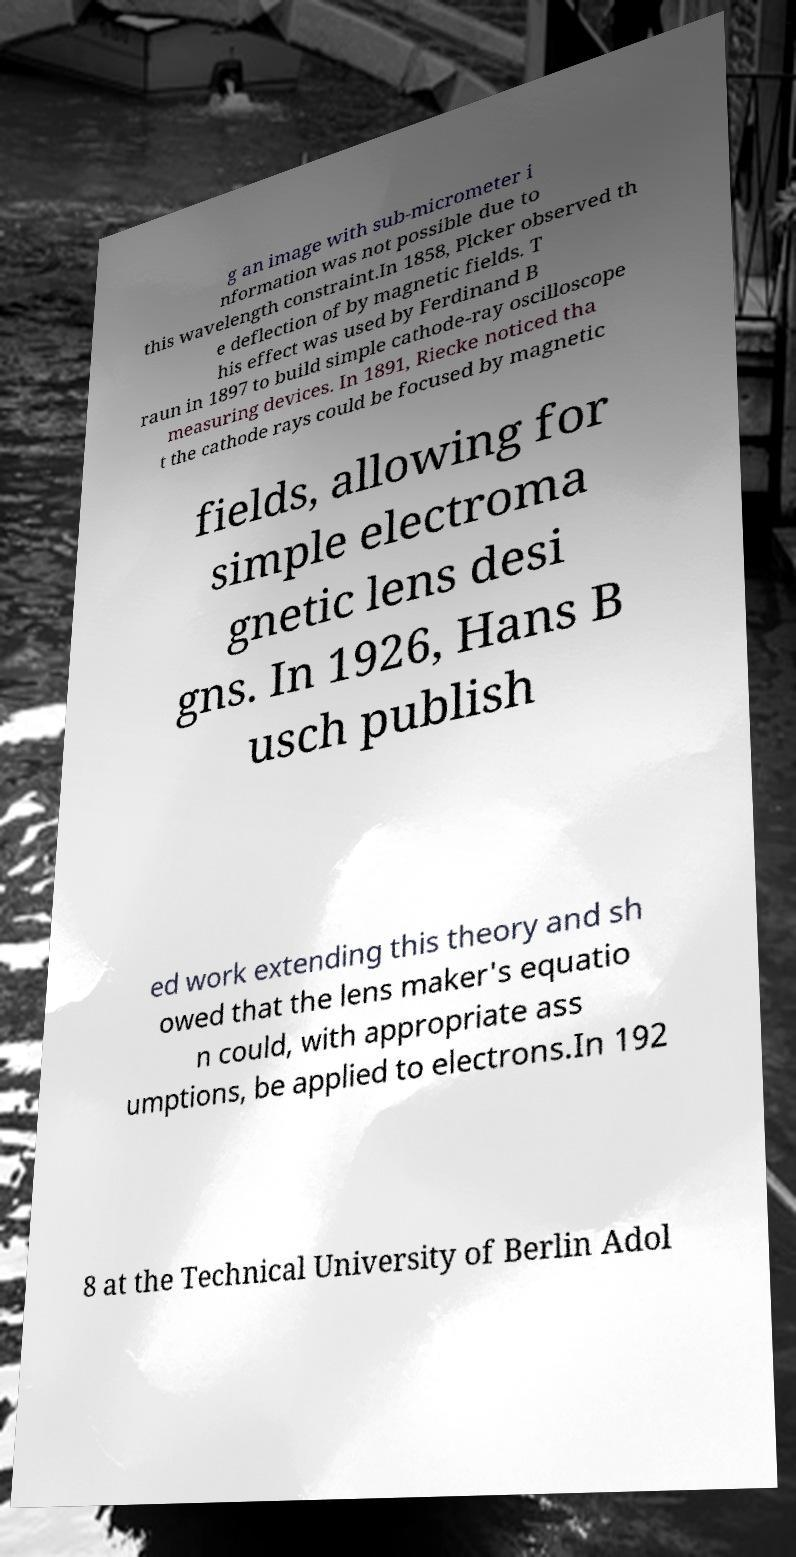Can you accurately transcribe the text from the provided image for me? g an image with sub-micrometer i nformation was not possible due to this wavelength constraint.In 1858, Plcker observed th e deflection of by magnetic fields. T his effect was used by Ferdinand B raun in 1897 to build simple cathode-ray oscilloscope measuring devices. In 1891, Riecke noticed tha t the cathode rays could be focused by magnetic fields, allowing for simple electroma gnetic lens desi gns. In 1926, Hans B usch publish ed work extending this theory and sh owed that the lens maker's equatio n could, with appropriate ass umptions, be applied to electrons.In 192 8 at the Technical University of Berlin Adol 